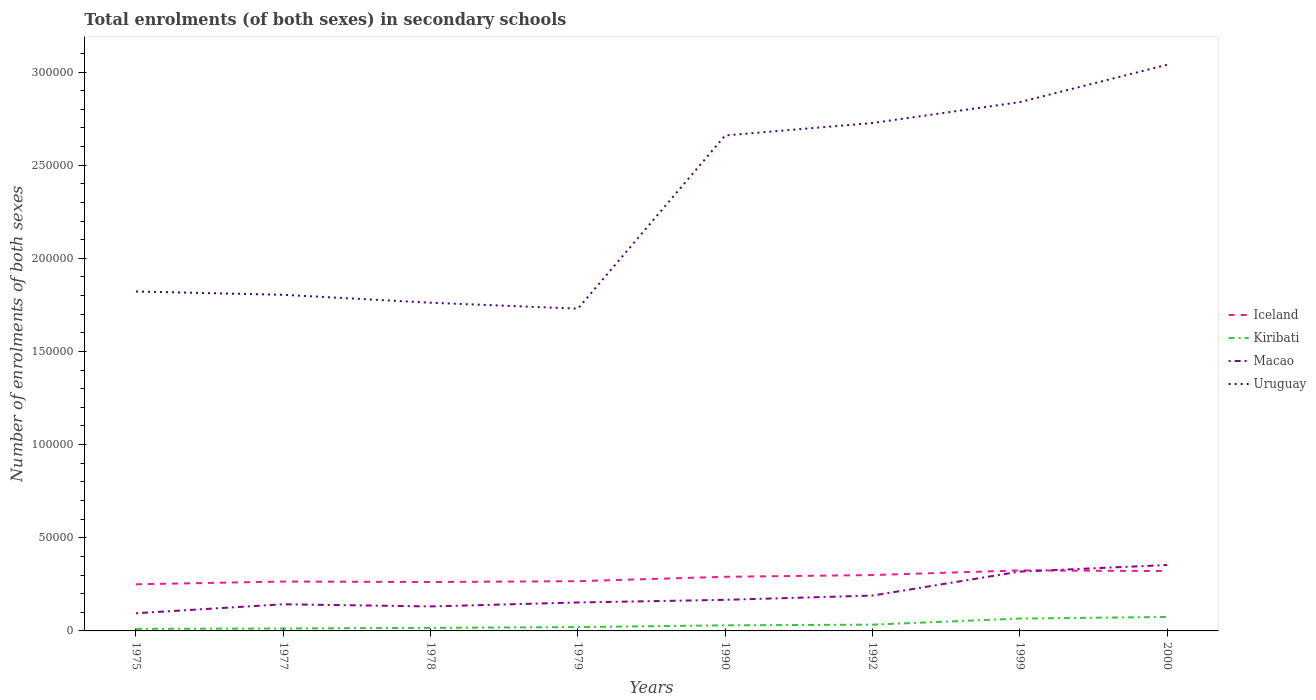Across all years, what is the maximum number of enrolments in secondary schools in Macao?
Give a very brief answer. 9498. In which year was the number of enrolments in secondary schools in Macao maximum?
Ensure brevity in your answer.  1975. What is the total number of enrolments in secondary schools in Macao in the graph?
Your response must be concise. -3508. What is the difference between the highest and the second highest number of enrolments in secondary schools in Iceland?
Ensure brevity in your answer.  7452. What is the difference between the highest and the lowest number of enrolments in secondary schools in Kiribati?
Your response must be concise. 3. Is the number of enrolments in secondary schools in Uruguay strictly greater than the number of enrolments in secondary schools in Iceland over the years?
Provide a short and direct response. No. How many lines are there?
Offer a terse response. 4. How many years are there in the graph?
Offer a terse response. 8. Where does the legend appear in the graph?
Offer a very short reply. Center right. How many legend labels are there?
Make the answer very short. 4. How are the legend labels stacked?
Make the answer very short. Vertical. What is the title of the graph?
Make the answer very short. Total enrolments (of both sexes) in secondary schools. Does "Suriname" appear as one of the legend labels in the graph?
Your response must be concise. No. What is the label or title of the Y-axis?
Your answer should be compact. Number of enrolments of both sexes. What is the Number of enrolments of both sexes of Iceland in 1975?
Keep it short and to the point. 2.50e+04. What is the Number of enrolments of both sexes in Kiribati in 1975?
Give a very brief answer. 1100. What is the Number of enrolments of both sexes in Macao in 1975?
Offer a terse response. 9498. What is the Number of enrolments of both sexes of Uruguay in 1975?
Give a very brief answer. 1.82e+05. What is the Number of enrolments of both sexes of Iceland in 1977?
Give a very brief answer. 2.65e+04. What is the Number of enrolments of both sexes in Kiribati in 1977?
Offer a terse response. 1300. What is the Number of enrolments of both sexes of Macao in 1977?
Your answer should be very brief. 1.43e+04. What is the Number of enrolments of both sexes in Uruguay in 1977?
Offer a very short reply. 1.80e+05. What is the Number of enrolments of both sexes of Iceland in 1978?
Offer a terse response. 2.63e+04. What is the Number of enrolments of both sexes of Kiribati in 1978?
Offer a very short reply. 1646. What is the Number of enrolments of both sexes in Macao in 1978?
Offer a terse response. 1.32e+04. What is the Number of enrolments of both sexes of Uruguay in 1978?
Provide a short and direct response. 1.76e+05. What is the Number of enrolments of both sexes in Iceland in 1979?
Give a very brief answer. 2.67e+04. What is the Number of enrolments of both sexes of Kiribati in 1979?
Give a very brief answer. 2062. What is the Number of enrolments of both sexes of Macao in 1979?
Provide a succinct answer. 1.53e+04. What is the Number of enrolments of both sexes of Uruguay in 1979?
Provide a short and direct response. 1.73e+05. What is the Number of enrolments of both sexes in Iceland in 1990?
Your answer should be very brief. 2.91e+04. What is the Number of enrolments of both sexes of Kiribati in 1990?
Keep it short and to the point. 3003. What is the Number of enrolments of both sexes of Macao in 1990?
Your answer should be compact. 1.67e+04. What is the Number of enrolments of both sexes of Uruguay in 1990?
Provide a succinct answer. 2.66e+05. What is the Number of enrolments of both sexes of Iceland in 1992?
Your answer should be compact. 3.00e+04. What is the Number of enrolments of both sexes of Kiribati in 1992?
Provide a short and direct response. 3357. What is the Number of enrolments of both sexes of Macao in 1992?
Your answer should be compact. 1.90e+04. What is the Number of enrolments of both sexes in Uruguay in 1992?
Make the answer very short. 2.73e+05. What is the Number of enrolments of both sexes in Iceland in 1999?
Offer a very short reply. 3.25e+04. What is the Number of enrolments of both sexes in Kiribati in 1999?
Offer a terse response. 6647. What is the Number of enrolments of both sexes of Macao in 1999?
Keep it short and to the point. 3.19e+04. What is the Number of enrolments of both sexes in Uruguay in 1999?
Your response must be concise. 2.84e+05. What is the Number of enrolments of both sexes of Iceland in 2000?
Ensure brevity in your answer.  3.21e+04. What is the Number of enrolments of both sexes in Kiribati in 2000?
Give a very brief answer. 7486. What is the Number of enrolments of both sexes in Macao in 2000?
Offer a very short reply. 3.54e+04. What is the Number of enrolments of both sexes of Uruguay in 2000?
Make the answer very short. 3.04e+05. Across all years, what is the maximum Number of enrolments of both sexes in Iceland?
Provide a succinct answer. 3.25e+04. Across all years, what is the maximum Number of enrolments of both sexes of Kiribati?
Your answer should be very brief. 7486. Across all years, what is the maximum Number of enrolments of both sexes in Macao?
Offer a very short reply. 3.54e+04. Across all years, what is the maximum Number of enrolments of both sexes of Uruguay?
Offer a terse response. 3.04e+05. Across all years, what is the minimum Number of enrolments of both sexes of Iceland?
Keep it short and to the point. 2.50e+04. Across all years, what is the minimum Number of enrolments of both sexes in Kiribati?
Offer a very short reply. 1100. Across all years, what is the minimum Number of enrolments of both sexes in Macao?
Your response must be concise. 9498. Across all years, what is the minimum Number of enrolments of both sexes of Uruguay?
Keep it short and to the point. 1.73e+05. What is the total Number of enrolments of both sexes of Iceland in the graph?
Offer a very short reply. 2.28e+05. What is the total Number of enrolments of both sexes of Kiribati in the graph?
Provide a short and direct response. 2.66e+04. What is the total Number of enrolments of both sexes in Macao in the graph?
Keep it short and to the point. 1.55e+05. What is the total Number of enrolments of both sexes in Uruguay in the graph?
Make the answer very short. 1.84e+06. What is the difference between the Number of enrolments of both sexes in Iceland in 1975 and that in 1977?
Keep it short and to the point. -1478. What is the difference between the Number of enrolments of both sexes of Kiribati in 1975 and that in 1977?
Make the answer very short. -200. What is the difference between the Number of enrolments of both sexes in Macao in 1975 and that in 1977?
Make the answer very short. -4807. What is the difference between the Number of enrolments of both sexes of Uruguay in 1975 and that in 1977?
Ensure brevity in your answer.  1777. What is the difference between the Number of enrolments of both sexes in Iceland in 1975 and that in 1978?
Give a very brief answer. -1223. What is the difference between the Number of enrolments of both sexes in Kiribati in 1975 and that in 1978?
Offer a very short reply. -546. What is the difference between the Number of enrolments of both sexes of Macao in 1975 and that in 1978?
Provide a short and direct response. -3652. What is the difference between the Number of enrolments of both sexes in Uruguay in 1975 and that in 1978?
Your answer should be compact. 6028. What is the difference between the Number of enrolments of both sexes of Iceland in 1975 and that in 1979?
Your answer should be very brief. -1671. What is the difference between the Number of enrolments of both sexes of Kiribati in 1975 and that in 1979?
Provide a succinct answer. -962. What is the difference between the Number of enrolments of both sexes in Macao in 1975 and that in 1979?
Give a very brief answer. -5770. What is the difference between the Number of enrolments of both sexes of Uruguay in 1975 and that in 1979?
Offer a very short reply. 9226. What is the difference between the Number of enrolments of both sexes in Iceland in 1975 and that in 1990?
Keep it short and to the point. -4031. What is the difference between the Number of enrolments of both sexes of Kiribati in 1975 and that in 1990?
Your answer should be very brief. -1903. What is the difference between the Number of enrolments of both sexes in Macao in 1975 and that in 1990?
Your answer should be compact. -7189. What is the difference between the Number of enrolments of both sexes in Uruguay in 1975 and that in 1990?
Offer a terse response. -8.38e+04. What is the difference between the Number of enrolments of both sexes in Iceland in 1975 and that in 1992?
Your answer should be very brief. -4957. What is the difference between the Number of enrolments of both sexes in Kiribati in 1975 and that in 1992?
Offer a terse response. -2257. What is the difference between the Number of enrolments of both sexes of Macao in 1975 and that in 1992?
Offer a very short reply. -9480. What is the difference between the Number of enrolments of both sexes of Uruguay in 1975 and that in 1992?
Offer a terse response. -9.04e+04. What is the difference between the Number of enrolments of both sexes of Iceland in 1975 and that in 1999?
Ensure brevity in your answer.  -7452. What is the difference between the Number of enrolments of both sexes in Kiribati in 1975 and that in 1999?
Ensure brevity in your answer.  -5547. What is the difference between the Number of enrolments of both sexes of Macao in 1975 and that in 1999?
Your response must be concise. -2.24e+04. What is the difference between the Number of enrolments of both sexes of Uruguay in 1975 and that in 1999?
Offer a very short reply. -1.02e+05. What is the difference between the Number of enrolments of both sexes in Iceland in 1975 and that in 2000?
Give a very brief answer. -7105. What is the difference between the Number of enrolments of both sexes of Kiribati in 1975 and that in 2000?
Make the answer very short. -6386. What is the difference between the Number of enrolments of both sexes in Macao in 1975 and that in 2000?
Provide a short and direct response. -2.59e+04. What is the difference between the Number of enrolments of both sexes of Uruguay in 1975 and that in 2000?
Keep it short and to the point. -1.22e+05. What is the difference between the Number of enrolments of both sexes of Iceland in 1977 and that in 1978?
Ensure brevity in your answer.  255. What is the difference between the Number of enrolments of both sexes in Kiribati in 1977 and that in 1978?
Your answer should be very brief. -346. What is the difference between the Number of enrolments of both sexes of Macao in 1977 and that in 1978?
Your response must be concise. 1155. What is the difference between the Number of enrolments of both sexes in Uruguay in 1977 and that in 1978?
Provide a succinct answer. 4251. What is the difference between the Number of enrolments of both sexes in Iceland in 1977 and that in 1979?
Keep it short and to the point. -193. What is the difference between the Number of enrolments of both sexes of Kiribati in 1977 and that in 1979?
Provide a short and direct response. -762. What is the difference between the Number of enrolments of both sexes in Macao in 1977 and that in 1979?
Your response must be concise. -963. What is the difference between the Number of enrolments of both sexes of Uruguay in 1977 and that in 1979?
Make the answer very short. 7449. What is the difference between the Number of enrolments of both sexes in Iceland in 1977 and that in 1990?
Your response must be concise. -2553. What is the difference between the Number of enrolments of both sexes in Kiribati in 1977 and that in 1990?
Provide a short and direct response. -1703. What is the difference between the Number of enrolments of both sexes in Macao in 1977 and that in 1990?
Your answer should be very brief. -2382. What is the difference between the Number of enrolments of both sexes in Uruguay in 1977 and that in 1990?
Offer a very short reply. -8.55e+04. What is the difference between the Number of enrolments of both sexes in Iceland in 1977 and that in 1992?
Offer a very short reply. -3479. What is the difference between the Number of enrolments of both sexes in Kiribati in 1977 and that in 1992?
Provide a succinct answer. -2057. What is the difference between the Number of enrolments of both sexes in Macao in 1977 and that in 1992?
Ensure brevity in your answer.  -4673. What is the difference between the Number of enrolments of both sexes of Uruguay in 1977 and that in 1992?
Offer a terse response. -9.22e+04. What is the difference between the Number of enrolments of both sexes in Iceland in 1977 and that in 1999?
Keep it short and to the point. -5974. What is the difference between the Number of enrolments of both sexes of Kiribati in 1977 and that in 1999?
Your answer should be very brief. -5347. What is the difference between the Number of enrolments of both sexes in Macao in 1977 and that in 1999?
Provide a short and direct response. -1.76e+04. What is the difference between the Number of enrolments of both sexes in Uruguay in 1977 and that in 1999?
Offer a very short reply. -1.03e+05. What is the difference between the Number of enrolments of both sexes in Iceland in 1977 and that in 2000?
Make the answer very short. -5627. What is the difference between the Number of enrolments of both sexes in Kiribati in 1977 and that in 2000?
Provide a succinct answer. -6186. What is the difference between the Number of enrolments of both sexes in Macao in 1977 and that in 2000?
Offer a very short reply. -2.11e+04. What is the difference between the Number of enrolments of both sexes in Uruguay in 1977 and that in 2000?
Provide a succinct answer. -1.23e+05. What is the difference between the Number of enrolments of both sexes in Iceland in 1978 and that in 1979?
Give a very brief answer. -448. What is the difference between the Number of enrolments of both sexes in Kiribati in 1978 and that in 1979?
Your answer should be very brief. -416. What is the difference between the Number of enrolments of both sexes in Macao in 1978 and that in 1979?
Make the answer very short. -2118. What is the difference between the Number of enrolments of both sexes in Uruguay in 1978 and that in 1979?
Make the answer very short. 3198. What is the difference between the Number of enrolments of both sexes in Iceland in 1978 and that in 1990?
Keep it short and to the point. -2808. What is the difference between the Number of enrolments of both sexes in Kiribati in 1978 and that in 1990?
Give a very brief answer. -1357. What is the difference between the Number of enrolments of both sexes in Macao in 1978 and that in 1990?
Provide a succinct answer. -3537. What is the difference between the Number of enrolments of both sexes in Uruguay in 1978 and that in 1990?
Provide a succinct answer. -8.98e+04. What is the difference between the Number of enrolments of both sexes in Iceland in 1978 and that in 1992?
Provide a succinct answer. -3734. What is the difference between the Number of enrolments of both sexes in Kiribati in 1978 and that in 1992?
Your answer should be compact. -1711. What is the difference between the Number of enrolments of both sexes in Macao in 1978 and that in 1992?
Offer a very short reply. -5828. What is the difference between the Number of enrolments of both sexes in Uruguay in 1978 and that in 1992?
Provide a short and direct response. -9.65e+04. What is the difference between the Number of enrolments of both sexes in Iceland in 1978 and that in 1999?
Offer a very short reply. -6229. What is the difference between the Number of enrolments of both sexes in Kiribati in 1978 and that in 1999?
Offer a very short reply. -5001. What is the difference between the Number of enrolments of both sexes of Macao in 1978 and that in 1999?
Your answer should be compact. -1.87e+04. What is the difference between the Number of enrolments of both sexes in Uruguay in 1978 and that in 1999?
Your answer should be compact. -1.08e+05. What is the difference between the Number of enrolments of both sexes of Iceland in 1978 and that in 2000?
Give a very brief answer. -5882. What is the difference between the Number of enrolments of both sexes of Kiribati in 1978 and that in 2000?
Provide a short and direct response. -5840. What is the difference between the Number of enrolments of both sexes of Macao in 1978 and that in 2000?
Your answer should be compact. -2.22e+04. What is the difference between the Number of enrolments of both sexes of Uruguay in 1978 and that in 2000?
Provide a succinct answer. -1.28e+05. What is the difference between the Number of enrolments of both sexes in Iceland in 1979 and that in 1990?
Provide a short and direct response. -2360. What is the difference between the Number of enrolments of both sexes in Kiribati in 1979 and that in 1990?
Ensure brevity in your answer.  -941. What is the difference between the Number of enrolments of both sexes in Macao in 1979 and that in 1990?
Ensure brevity in your answer.  -1419. What is the difference between the Number of enrolments of both sexes in Uruguay in 1979 and that in 1990?
Provide a succinct answer. -9.30e+04. What is the difference between the Number of enrolments of both sexes in Iceland in 1979 and that in 1992?
Offer a very short reply. -3286. What is the difference between the Number of enrolments of both sexes in Kiribati in 1979 and that in 1992?
Provide a short and direct response. -1295. What is the difference between the Number of enrolments of both sexes of Macao in 1979 and that in 1992?
Offer a very short reply. -3710. What is the difference between the Number of enrolments of both sexes of Uruguay in 1979 and that in 1992?
Make the answer very short. -9.97e+04. What is the difference between the Number of enrolments of both sexes in Iceland in 1979 and that in 1999?
Your answer should be compact. -5781. What is the difference between the Number of enrolments of both sexes of Kiribati in 1979 and that in 1999?
Provide a short and direct response. -4585. What is the difference between the Number of enrolments of both sexes in Macao in 1979 and that in 1999?
Keep it short and to the point. -1.66e+04. What is the difference between the Number of enrolments of both sexes in Uruguay in 1979 and that in 1999?
Provide a short and direct response. -1.11e+05. What is the difference between the Number of enrolments of both sexes in Iceland in 1979 and that in 2000?
Give a very brief answer. -5434. What is the difference between the Number of enrolments of both sexes in Kiribati in 1979 and that in 2000?
Ensure brevity in your answer.  -5424. What is the difference between the Number of enrolments of both sexes in Macao in 1979 and that in 2000?
Your response must be concise. -2.01e+04. What is the difference between the Number of enrolments of both sexes in Uruguay in 1979 and that in 2000?
Your response must be concise. -1.31e+05. What is the difference between the Number of enrolments of both sexes of Iceland in 1990 and that in 1992?
Ensure brevity in your answer.  -926. What is the difference between the Number of enrolments of both sexes in Kiribati in 1990 and that in 1992?
Make the answer very short. -354. What is the difference between the Number of enrolments of both sexes of Macao in 1990 and that in 1992?
Offer a terse response. -2291. What is the difference between the Number of enrolments of both sexes in Uruguay in 1990 and that in 1992?
Your answer should be very brief. -6675. What is the difference between the Number of enrolments of both sexes in Iceland in 1990 and that in 1999?
Keep it short and to the point. -3421. What is the difference between the Number of enrolments of both sexes of Kiribati in 1990 and that in 1999?
Make the answer very short. -3644. What is the difference between the Number of enrolments of both sexes in Macao in 1990 and that in 1999?
Offer a terse response. -1.52e+04. What is the difference between the Number of enrolments of both sexes of Uruguay in 1990 and that in 1999?
Offer a terse response. -1.79e+04. What is the difference between the Number of enrolments of both sexes in Iceland in 1990 and that in 2000?
Your answer should be very brief. -3074. What is the difference between the Number of enrolments of both sexes of Kiribati in 1990 and that in 2000?
Your response must be concise. -4483. What is the difference between the Number of enrolments of both sexes in Macao in 1990 and that in 2000?
Provide a succinct answer. -1.87e+04. What is the difference between the Number of enrolments of both sexes in Uruguay in 1990 and that in 2000?
Your response must be concise. -3.79e+04. What is the difference between the Number of enrolments of both sexes of Iceland in 1992 and that in 1999?
Make the answer very short. -2495. What is the difference between the Number of enrolments of both sexes of Kiribati in 1992 and that in 1999?
Offer a terse response. -3290. What is the difference between the Number of enrolments of both sexes in Macao in 1992 and that in 1999?
Provide a succinct answer. -1.29e+04. What is the difference between the Number of enrolments of both sexes in Uruguay in 1992 and that in 1999?
Provide a short and direct response. -1.12e+04. What is the difference between the Number of enrolments of both sexes of Iceland in 1992 and that in 2000?
Give a very brief answer. -2148. What is the difference between the Number of enrolments of both sexes in Kiribati in 1992 and that in 2000?
Make the answer very short. -4129. What is the difference between the Number of enrolments of both sexes in Macao in 1992 and that in 2000?
Provide a short and direct response. -1.64e+04. What is the difference between the Number of enrolments of both sexes in Uruguay in 1992 and that in 2000?
Ensure brevity in your answer.  -3.13e+04. What is the difference between the Number of enrolments of both sexes of Iceland in 1999 and that in 2000?
Your answer should be very brief. 347. What is the difference between the Number of enrolments of both sexes of Kiribati in 1999 and that in 2000?
Keep it short and to the point. -839. What is the difference between the Number of enrolments of both sexes of Macao in 1999 and that in 2000?
Provide a short and direct response. -3508. What is the difference between the Number of enrolments of both sexes of Uruguay in 1999 and that in 2000?
Give a very brief answer. -2.00e+04. What is the difference between the Number of enrolments of both sexes in Iceland in 1975 and the Number of enrolments of both sexes in Kiribati in 1977?
Your response must be concise. 2.37e+04. What is the difference between the Number of enrolments of both sexes of Iceland in 1975 and the Number of enrolments of both sexes of Macao in 1977?
Keep it short and to the point. 1.07e+04. What is the difference between the Number of enrolments of both sexes in Iceland in 1975 and the Number of enrolments of both sexes in Uruguay in 1977?
Make the answer very short. -1.55e+05. What is the difference between the Number of enrolments of both sexes of Kiribati in 1975 and the Number of enrolments of both sexes of Macao in 1977?
Your answer should be very brief. -1.32e+04. What is the difference between the Number of enrolments of both sexes of Kiribati in 1975 and the Number of enrolments of both sexes of Uruguay in 1977?
Offer a terse response. -1.79e+05. What is the difference between the Number of enrolments of both sexes of Macao in 1975 and the Number of enrolments of both sexes of Uruguay in 1977?
Ensure brevity in your answer.  -1.71e+05. What is the difference between the Number of enrolments of both sexes of Iceland in 1975 and the Number of enrolments of both sexes of Kiribati in 1978?
Provide a short and direct response. 2.34e+04. What is the difference between the Number of enrolments of both sexes of Iceland in 1975 and the Number of enrolments of both sexes of Macao in 1978?
Provide a short and direct response. 1.19e+04. What is the difference between the Number of enrolments of both sexes in Iceland in 1975 and the Number of enrolments of both sexes in Uruguay in 1978?
Your answer should be very brief. -1.51e+05. What is the difference between the Number of enrolments of both sexes of Kiribati in 1975 and the Number of enrolments of both sexes of Macao in 1978?
Your response must be concise. -1.20e+04. What is the difference between the Number of enrolments of both sexes of Kiribati in 1975 and the Number of enrolments of both sexes of Uruguay in 1978?
Provide a short and direct response. -1.75e+05. What is the difference between the Number of enrolments of both sexes of Macao in 1975 and the Number of enrolments of both sexes of Uruguay in 1978?
Provide a succinct answer. -1.67e+05. What is the difference between the Number of enrolments of both sexes in Iceland in 1975 and the Number of enrolments of both sexes in Kiribati in 1979?
Give a very brief answer. 2.30e+04. What is the difference between the Number of enrolments of both sexes of Iceland in 1975 and the Number of enrolments of both sexes of Macao in 1979?
Provide a succinct answer. 9760. What is the difference between the Number of enrolments of both sexes in Iceland in 1975 and the Number of enrolments of both sexes in Uruguay in 1979?
Your answer should be very brief. -1.48e+05. What is the difference between the Number of enrolments of both sexes of Kiribati in 1975 and the Number of enrolments of both sexes of Macao in 1979?
Offer a terse response. -1.42e+04. What is the difference between the Number of enrolments of both sexes in Kiribati in 1975 and the Number of enrolments of both sexes in Uruguay in 1979?
Offer a terse response. -1.72e+05. What is the difference between the Number of enrolments of both sexes in Macao in 1975 and the Number of enrolments of both sexes in Uruguay in 1979?
Give a very brief answer. -1.63e+05. What is the difference between the Number of enrolments of both sexes of Iceland in 1975 and the Number of enrolments of both sexes of Kiribati in 1990?
Ensure brevity in your answer.  2.20e+04. What is the difference between the Number of enrolments of both sexes in Iceland in 1975 and the Number of enrolments of both sexes in Macao in 1990?
Your answer should be very brief. 8341. What is the difference between the Number of enrolments of both sexes of Iceland in 1975 and the Number of enrolments of both sexes of Uruguay in 1990?
Your answer should be very brief. -2.41e+05. What is the difference between the Number of enrolments of both sexes in Kiribati in 1975 and the Number of enrolments of both sexes in Macao in 1990?
Provide a short and direct response. -1.56e+04. What is the difference between the Number of enrolments of both sexes of Kiribati in 1975 and the Number of enrolments of both sexes of Uruguay in 1990?
Your answer should be compact. -2.65e+05. What is the difference between the Number of enrolments of both sexes of Macao in 1975 and the Number of enrolments of both sexes of Uruguay in 1990?
Give a very brief answer. -2.56e+05. What is the difference between the Number of enrolments of both sexes of Iceland in 1975 and the Number of enrolments of both sexes of Kiribati in 1992?
Make the answer very short. 2.17e+04. What is the difference between the Number of enrolments of both sexes in Iceland in 1975 and the Number of enrolments of both sexes in Macao in 1992?
Provide a short and direct response. 6050. What is the difference between the Number of enrolments of both sexes in Iceland in 1975 and the Number of enrolments of both sexes in Uruguay in 1992?
Ensure brevity in your answer.  -2.48e+05. What is the difference between the Number of enrolments of both sexes of Kiribati in 1975 and the Number of enrolments of both sexes of Macao in 1992?
Provide a succinct answer. -1.79e+04. What is the difference between the Number of enrolments of both sexes in Kiribati in 1975 and the Number of enrolments of both sexes in Uruguay in 1992?
Make the answer very short. -2.72e+05. What is the difference between the Number of enrolments of both sexes of Macao in 1975 and the Number of enrolments of both sexes of Uruguay in 1992?
Your answer should be compact. -2.63e+05. What is the difference between the Number of enrolments of both sexes of Iceland in 1975 and the Number of enrolments of both sexes of Kiribati in 1999?
Provide a succinct answer. 1.84e+04. What is the difference between the Number of enrolments of both sexes of Iceland in 1975 and the Number of enrolments of both sexes of Macao in 1999?
Your response must be concise. -6831. What is the difference between the Number of enrolments of both sexes of Iceland in 1975 and the Number of enrolments of both sexes of Uruguay in 1999?
Keep it short and to the point. -2.59e+05. What is the difference between the Number of enrolments of both sexes of Kiribati in 1975 and the Number of enrolments of both sexes of Macao in 1999?
Ensure brevity in your answer.  -3.08e+04. What is the difference between the Number of enrolments of both sexes in Kiribati in 1975 and the Number of enrolments of both sexes in Uruguay in 1999?
Offer a very short reply. -2.83e+05. What is the difference between the Number of enrolments of both sexes of Macao in 1975 and the Number of enrolments of both sexes of Uruguay in 1999?
Offer a terse response. -2.74e+05. What is the difference between the Number of enrolments of both sexes of Iceland in 1975 and the Number of enrolments of both sexes of Kiribati in 2000?
Provide a succinct answer. 1.75e+04. What is the difference between the Number of enrolments of both sexes of Iceland in 1975 and the Number of enrolments of both sexes of Macao in 2000?
Your answer should be compact. -1.03e+04. What is the difference between the Number of enrolments of both sexes of Iceland in 1975 and the Number of enrolments of both sexes of Uruguay in 2000?
Your answer should be very brief. -2.79e+05. What is the difference between the Number of enrolments of both sexes of Kiribati in 1975 and the Number of enrolments of both sexes of Macao in 2000?
Keep it short and to the point. -3.43e+04. What is the difference between the Number of enrolments of both sexes in Kiribati in 1975 and the Number of enrolments of both sexes in Uruguay in 2000?
Your response must be concise. -3.03e+05. What is the difference between the Number of enrolments of both sexes in Macao in 1975 and the Number of enrolments of both sexes in Uruguay in 2000?
Your answer should be compact. -2.94e+05. What is the difference between the Number of enrolments of both sexes of Iceland in 1977 and the Number of enrolments of both sexes of Kiribati in 1978?
Offer a very short reply. 2.49e+04. What is the difference between the Number of enrolments of both sexes of Iceland in 1977 and the Number of enrolments of both sexes of Macao in 1978?
Your answer should be very brief. 1.34e+04. What is the difference between the Number of enrolments of both sexes in Iceland in 1977 and the Number of enrolments of both sexes in Uruguay in 1978?
Provide a short and direct response. -1.50e+05. What is the difference between the Number of enrolments of both sexes in Kiribati in 1977 and the Number of enrolments of both sexes in Macao in 1978?
Your answer should be very brief. -1.18e+04. What is the difference between the Number of enrolments of both sexes of Kiribati in 1977 and the Number of enrolments of both sexes of Uruguay in 1978?
Give a very brief answer. -1.75e+05. What is the difference between the Number of enrolments of both sexes in Macao in 1977 and the Number of enrolments of both sexes in Uruguay in 1978?
Your answer should be very brief. -1.62e+05. What is the difference between the Number of enrolments of both sexes of Iceland in 1977 and the Number of enrolments of both sexes of Kiribati in 1979?
Offer a terse response. 2.44e+04. What is the difference between the Number of enrolments of both sexes of Iceland in 1977 and the Number of enrolments of both sexes of Macao in 1979?
Offer a terse response. 1.12e+04. What is the difference between the Number of enrolments of both sexes in Iceland in 1977 and the Number of enrolments of both sexes in Uruguay in 1979?
Ensure brevity in your answer.  -1.46e+05. What is the difference between the Number of enrolments of both sexes in Kiribati in 1977 and the Number of enrolments of both sexes in Macao in 1979?
Keep it short and to the point. -1.40e+04. What is the difference between the Number of enrolments of both sexes in Kiribati in 1977 and the Number of enrolments of both sexes in Uruguay in 1979?
Keep it short and to the point. -1.72e+05. What is the difference between the Number of enrolments of both sexes of Macao in 1977 and the Number of enrolments of both sexes of Uruguay in 1979?
Ensure brevity in your answer.  -1.59e+05. What is the difference between the Number of enrolments of both sexes of Iceland in 1977 and the Number of enrolments of both sexes of Kiribati in 1990?
Provide a succinct answer. 2.35e+04. What is the difference between the Number of enrolments of both sexes in Iceland in 1977 and the Number of enrolments of both sexes in Macao in 1990?
Ensure brevity in your answer.  9819. What is the difference between the Number of enrolments of both sexes of Iceland in 1977 and the Number of enrolments of both sexes of Uruguay in 1990?
Offer a terse response. -2.39e+05. What is the difference between the Number of enrolments of both sexes of Kiribati in 1977 and the Number of enrolments of both sexes of Macao in 1990?
Make the answer very short. -1.54e+04. What is the difference between the Number of enrolments of both sexes in Kiribati in 1977 and the Number of enrolments of both sexes in Uruguay in 1990?
Your answer should be compact. -2.65e+05. What is the difference between the Number of enrolments of both sexes of Macao in 1977 and the Number of enrolments of both sexes of Uruguay in 1990?
Offer a very short reply. -2.52e+05. What is the difference between the Number of enrolments of both sexes of Iceland in 1977 and the Number of enrolments of both sexes of Kiribati in 1992?
Provide a succinct answer. 2.31e+04. What is the difference between the Number of enrolments of both sexes in Iceland in 1977 and the Number of enrolments of both sexes in Macao in 1992?
Your response must be concise. 7528. What is the difference between the Number of enrolments of both sexes of Iceland in 1977 and the Number of enrolments of both sexes of Uruguay in 1992?
Provide a succinct answer. -2.46e+05. What is the difference between the Number of enrolments of both sexes of Kiribati in 1977 and the Number of enrolments of both sexes of Macao in 1992?
Your answer should be very brief. -1.77e+04. What is the difference between the Number of enrolments of both sexes in Kiribati in 1977 and the Number of enrolments of both sexes in Uruguay in 1992?
Offer a very short reply. -2.71e+05. What is the difference between the Number of enrolments of both sexes in Macao in 1977 and the Number of enrolments of both sexes in Uruguay in 1992?
Give a very brief answer. -2.58e+05. What is the difference between the Number of enrolments of both sexes in Iceland in 1977 and the Number of enrolments of both sexes in Kiribati in 1999?
Provide a short and direct response. 1.99e+04. What is the difference between the Number of enrolments of both sexes in Iceland in 1977 and the Number of enrolments of both sexes in Macao in 1999?
Provide a succinct answer. -5353. What is the difference between the Number of enrolments of both sexes of Iceland in 1977 and the Number of enrolments of both sexes of Uruguay in 1999?
Offer a very short reply. -2.57e+05. What is the difference between the Number of enrolments of both sexes of Kiribati in 1977 and the Number of enrolments of both sexes of Macao in 1999?
Ensure brevity in your answer.  -3.06e+04. What is the difference between the Number of enrolments of both sexes in Kiribati in 1977 and the Number of enrolments of both sexes in Uruguay in 1999?
Offer a terse response. -2.83e+05. What is the difference between the Number of enrolments of both sexes in Macao in 1977 and the Number of enrolments of both sexes in Uruguay in 1999?
Make the answer very short. -2.70e+05. What is the difference between the Number of enrolments of both sexes of Iceland in 1977 and the Number of enrolments of both sexes of Kiribati in 2000?
Offer a terse response. 1.90e+04. What is the difference between the Number of enrolments of both sexes in Iceland in 1977 and the Number of enrolments of both sexes in Macao in 2000?
Your answer should be compact. -8861. What is the difference between the Number of enrolments of both sexes of Iceland in 1977 and the Number of enrolments of both sexes of Uruguay in 2000?
Make the answer very short. -2.77e+05. What is the difference between the Number of enrolments of both sexes of Kiribati in 1977 and the Number of enrolments of both sexes of Macao in 2000?
Your answer should be compact. -3.41e+04. What is the difference between the Number of enrolments of both sexes of Kiribati in 1977 and the Number of enrolments of both sexes of Uruguay in 2000?
Your answer should be very brief. -3.03e+05. What is the difference between the Number of enrolments of both sexes in Macao in 1977 and the Number of enrolments of both sexes in Uruguay in 2000?
Offer a very short reply. -2.90e+05. What is the difference between the Number of enrolments of both sexes of Iceland in 1978 and the Number of enrolments of both sexes of Kiribati in 1979?
Offer a very short reply. 2.42e+04. What is the difference between the Number of enrolments of both sexes in Iceland in 1978 and the Number of enrolments of both sexes in Macao in 1979?
Your answer should be compact. 1.10e+04. What is the difference between the Number of enrolments of both sexes of Iceland in 1978 and the Number of enrolments of both sexes of Uruguay in 1979?
Your answer should be very brief. -1.47e+05. What is the difference between the Number of enrolments of both sexes in Kiribati in 1978 and the Number of enrolments of both sexes in Macao in 1979?
Offer a terse response. -1.36e+04. What is the difference between the Number of enrolments of both sexes in Kiribati in 1978 and the Number of enrolments of both sexes in Uruguay in 1979?
Ensure brevity in your answer.  -1.71e+05. What is the difference between the Number of enrolments of both sexes of Macao in 1978 and the Number of enrolments of both sexes of Uruguay in 1979?
Your response must be concise. -1.60e+05. What is the difference between the Number of enrolments of both sexes of Iceland in 1978 and the Number of enrolments of both sexes of Kiribati in 1990?
Your answer should be compact. 2.32e+04. What is the difference between the Number of enrolments of both sexes in Iceland in 1978 and the Number of enrolments of both sexes in Macao in 1990?
Provide a succinct answer. 9564. What is the difference between the Number of enrolments of both sexes of Iceland in 1978 and the Number of enrolments of both sexes of Uruguay in 1990?
Your response must be concise. -2.40e+05. What is the difference between the Number of enrolments of both sexes in Kiribati in 1978 and the Number of enrolments of both sexes in Macao in 1990?
Provide a short and direct response. -1.50e+04. What is the difference between the Number of enrolments of both sexes of Kiribati in 1978 and the Number of enrolments of both sexes of Uruguay in 1990?
Offer a terse response. -2.64e+05. What is the difference between the Number of enrolments of both sexes of Macao in 1978 and the Number of enrolments of both sexes of Uruguay in 1990?
Offer a very short reply. -2.53e+05. What is the difference between the Number of enrolments of both sexes in Iceland in 1978 and the Number of enrolments of both sexes in Kiribati in 1992?
Keep it short and to the point. 2.29e+04. What is the difference between the Number of enrolments of both sexes in Iceland in 1978 and the Number of enrolments of both sexes in Macao in 1992?
Give a very brief answer. 7273. What is the difference between the Number of enrolments of both sexes in Iceland in 1978 and the Number of enrolments of both sexes in Uruguay in 1992?
Your answer should be very brief. -2.46e+05. What is the difference between the Number of enrolments of both sexes in Kiribati in 1978 and the Number of enrolments of both sexes in Macao in 1992?
Make the answer very short. -1.73e+04. What is the difference between the Number of enrolments of both sexes in Kiribati in 1978 and the Number of enrolments of both sexes in Uruguay in 1992?
Offer a terse response. -2.71e+05. What is the difference between the Number of enrolments of both sexes of Macao in 1978 and the Number of enrolments of both sexes of Uruguay in 1992?
Make the answer very short. -2.59e+05. What is the difference between the Number of enrolments of both sexes in Iceland in 1978 and the Number of enrolments of both sexes in Kiribati in 1999?
Make the answer very short. 1.96e+04. What is the difference between the Number of enrolments of both sexes of Iceland in 1978 and the Number of enrolments of both sexes of Macao in 1999?
Ensure brevity in your answer.  -5608. What is the difference between the Number of enrolments of both sexes in Iceland in 1978 and the Number of enrolments of both sexes in Uruguay in 1999?
Provide a short and direct response. -2.58e+05. What is the difference between the Number of enrolments of both sexes in Kiribati in 1978 and the Number of enrolments of both sexes in Macao in 1999?
Provide a short and direct response. -3.02e+04. What is the difference between the Number of enrolments of both sexes of Kiribati in 1978 and the Number of enrolments of both sexes of Uruguay in 1999?
Give a very brief answer. -2.82e+05. What is the difference between the Number of enrolments of both sexes of Macao in 1978 and the Number of enrolments of both sexes of Uruguay in 1999?
Provide a succinct answer. -2.71e+05. What is the difference between the Number of enrolments of both sexes of Iceland in 1978 and the Number of enrolments of both sexes of Kiribati in 2000?
Your answer should be very brief. 1.88e+04. What is the difference between the Number of enrolments of both sexes in Iceland in 1978 and the Number of enrolments of both sexes in Macao in 2000?
Offer a terse response. -9116. What is the difference between the Number of enrolments of both sexes of Iceland in 1978 and the Number of enrolments of both sexes of Uruguay in 2000?
Give a very brief answer. -2.78e+05. What is the difference between the Number of enrolments of both sexes of Kiribati in 1978 and the Number of enrolments of both sexes of Macao in 2000?
Offer a very short reply. -3.37e+04. What is the difference between the Number of enrolments of both sexes of Kiribati in 1978 and the Number of enrolments of both sexes of Uruguay in 2000?
Offer a terse response. -3.02e+05. What is the difference between the Number of enrolments of both sexes in Macao in 1978 and the Number of enrolments of both sexes in Uruguay in 2000?
Give a very brief answer. -2.91e+05. What is the difference between the Number of enrolments of both sexes of Iceland in 1979 and the Number of enrolments of both sexes of Kiribati in 1990?
Your answer should be compact. 2.37e+04. What is the difference between the Number of enrolments of both sexes in Iceland in 1979 and the Number of enrolments of both sexes in Macao in 1990?
Make the answer very short. 1.00e+04. What is the difference between the Number of enrolments of both sexes of Iceland in 1979 and the Number of enrolments of both sexes of Uruguay in 1990?
Give a very brief answer. -2.39e+05. What is the difference between the Number of enrolments of both sexes of Kiribati in 1979 and the Number of enrolments of both sexes of Macao in 1990?
Provide a succinct answer. -1.46e+04. What is the difference between the Number of enrolments of both sexes of Kiribati in 1979 and the Number of enrolments of both sexes of Uruguay in 1990?
Make the answer very short. -2.64e+05. What is the difference between the Number of enrolments of both sexes in Macao in 1979 and the Number of enrolments of both sexes in Uruguay in 1990?
Make the answer very short. -2.51e+05. What is the difference between the Number of enrolments of both sexes of Iceland in 1979 and the Number of enrolments of both sexes of Kiribati in 1992?
Provide a short and direct response. 2.33e+04. What is the difference between the Number of enrolments of both sexes of Iceland in 1979 and the Number of enrolments of both sexes of Macao in 1992?
Provide a succinct answer. 7721. What is the difference between the Number of enrolments of both sexes in Iceland in 1979 and the Number of enrolments of both sexes in Uruguay in 1992?
Make the answer very short. -2.46e+05. What is the difference between the Number of enrolments of both sexes of Kiribati in 1979 and the Number of enrolments of both sexes of Macao in 1992?
Give a very brief answer. -1.69e+04. What is the difference between the Number of enrolments of both sexes of Kiribati in 1979 and the Number of enrolments of both sexes of Uruguay in 1992?
Provide a short and direct response. -2.71e+05. What is the difference between the Number of enrolments of both sexes in Macao in 1979 and the Number of enrolments of both sexes in Uruguay in 1992?
Offer a terse response. -2.57e+05. What is the difference between the Number of enrolments of both sexes in Iceland in 1979 and the Number of enrolments of both sexes in Kiribati in 1999?
Offer a very short reply. 2.01e+04. What is the difference between the Number of enrolments of both sexes of Iceland in 1979 and the Number of enrolments of both sexes of Macao in 1999?
Provide a succinct answer. -5160. What is the difference between the Number of enrolments of both sexes of Iceland in 1979 and the Number of enrolments of both sexes of Uruguay in 1999?
Give a very brief answer. -2.57e+05. What is the difference between the Number of enrolments of both sexes in Kiribati in 1979 and the Number of enrolments of both sexes in Macao in 1999?
Ensure brevity in your answer.  -2.98e+04. What is the difference between the Number of enrolments of both sexes of Kiribati in 1979 and the Number of enrolments of both sexes of Uruguay in 1999?
Offer a very short reply. -2.82e+05. What is the difference between the Number of enrolments of both sexes in Macao in 1979 and the Number of enrolments of both sexes in Uruguay in 1999?
Give a very brief answer. -2.69e+05. What is the difference between the Number of enrolments of both sexes in Iceland in 1979 and the Number of enrolments of both sexes in Kiribati in 2000?
Provide a succinct answer. 1.92e+04. What is the difference between the Number of enrolments of both sexes in Iceland in 1979 and the Number of enrolments of both sexes in Macao in 2000?
Provide a succinct answer. -8668. What is the difference between the Number of enrolments of both sexes in Iceland in 1979 and the Number of enrolments of both sexes in Uruguay in 2000?
Offer a very short reply. -2.77e+05. What is the difference between the Number of enrolments of both sexes in Kiribati in 1979 and the Number of enrolments of both sexes in Macao in 2000?
Provide a succinct answer. -3.33e+04. What is the difference between the Number of enrolments of both sexes of Kiribati in 1979 and the Number of enrolments of both sexes of Uruguay in 2000?
Your response must be concise. -3.02e+05. What is the difference between the Number of enrolments of both sexes in Macao in 1979 and the Number of enrolments of both sexes in Uruguay in 2000?
Provide a short and direct response. -2.89e+05. What is the difference between the Number of enrolments of both sexes in Iceland in 1990 and the Number of enrolments of both sexes in Kiribati in 1992?
Your answer should be very brief. 2.57e+04. What is the difference between the Number of enrolments of both sexes of Iceland in 1990 and the Number of enrolments of both sexes of Macao in 1992?
Your response must be concise. 1.01e+04. What is the difference between the Number of enrolments of both sexes of Iceland in 1990 and the Number of enrolments of both sexes of Uruguay in 1992?
Your answer should be compact. -2.44e+05. What is the difference between the Number of enrolments of both sexes in Kiribati in 1990 and the Number of enrolments of both sexes in Macao in 1992?
Make the answer very short. -1.60e+04. What is the difference between the Number of enrolments of both sexes of Kiribati in 1990 and the Number of enrolments of both sexes of Uruguay in 1992?
Offer a very short reply. -2.70e+05. What is the difference between the Number of enrolments of both sexes of Macao in 1990 and the Number of enrolments of both sexes of Uruguay in 1992?
Your answer should be compact. -2.56e+05. What is the difference between the Number of enrolments of both sexes of Iceland in 1990 and the Number of enrolments of both sexes of Kiribati in 1999?
Your response must be concise. 2.24e+04. What is the difference between the Number of enrolments of both sexes in Iceland in 1990 and the Number of enrolments of both sexes in Macao in 1999?
Your answer should be compact. -2800. What is the difference between the Number of enrolments of both sexes in Iceland in 1990 and the Number of enrolments of both sexes in Uruguay in 1999?
Give a very brief answer. -2.55e+05. What is the difference between the Number of enrolments of both sexes of Kiribati in 1990 and the Number of enrolments of both sexes of Macao in 1999?
Provide a short and direct response. -2.89e+04. What is the difference between the Number of enrolments of both sexes of Kiribati in 1990 and the Number of enrolments of both sexes of Uruguay in 1999?
Offer a terse response. -2.81e+05. What is the difference between the Number of enrolments of both sexes in Macao in 1990 and the Number of enrolments of both sexes in Uruguay in 1999?
Your answer should be compact. -2.67e+05. What is the difference between the Number of enrolments of both sexes in Iceland in 1990 and the Number of enrolments of both sexes in Kiribati in 2000?
Your answer should be very brief. 2.16e+04. What is the difference between the Number of enrolments of both sexes in Iceland in 1990 and the Number of enrolments of both sexes in Macao in 2000?
Provide a succinct answer. -6308. What is the difference between the Number of enrolments of both sexes of Iceland in 1990 and the Number of enrolments of both sexes of Uruguay in 2000?
Your answer should be very brief. -2.75e+05. What is the difference between the Number of enrolments of both sexes of Kiribati in 1990 and the Number of enrolments of both sexes of Macao in 2000?
Offer a terse response. -3.24e+04. What is the difference between the Number of enrolments of both sexes in Kiribati in 1990 and the Number of enrolments of both sexes in Uruguay in 2000?
Your answer should be compact. -3.01e+05. What is the difference between the Number of enrolments of both sexes in Macao in 1990 and the Number of enrolments of both sexes in Uruguay in 2000?
Keep it short and to the point. -2.87e+05. What is the difference between the Number of enrolments of both sexes in Iceland in 1992 and the Number of enrolments of both sexes in Kiribati in 1999?
Ensure brevity in your answer.  2.33e+04. What is the difference between the Number of enrolments of both sexes in Iceland in 1992 and the Number of enrolments of both sexes in Macao in 1999?
Your response must be concise. -1874. What is the difference between the Number of enrolments of both sexes in Iceland in 1992 and the Number of enrolments of both sexes in Uruguay in 1999?
Provide a short and direct response. -2.54e+05. What is the difference between the Number of enrolments of both sexes of Kiribati in 1992 and the Number of enrolments of both sexes of Macao in 1999?
Offer a very short reply. -2.85e+04. What is the difference between the Number of enrolments of both sexes of Kiribati in 1992 and the Number of enrolments of both sexes of Uruguay in 1999?
Keep it short and to the point. -2.80e+05. What is the difference between the Number of enrolments of both sexes in Macao in 1992 and the Number of enrolments of both sexes in Uruguay in 1999?
Provide a succinct answer. -2.65e+05. What is the difference between the Number of enrolments of both sexes of Iceland in 1992 and the Number of enrolments of both sexes of Kiribati in 2000?
Offer a very short reply. 2.25e+04. What is the difference between the Number of enrolments of both sexes of Iceland in 1992 and the Number of enrolments of both sexes of Macao in 2000?
Your answer should be compact. -5382. What is the difference between the Number of enrolments of both sexes in Iceland in 1992 and the Number of enrolments of both sexes in Uruguay in 2000?
Your response must be concise. -2.74e+05. What is the difference between the Number of enrolments of both sexes of Kiribati in 1992 and the Number of enrolments of both sexes of Macao in 2000?
Ensure brevity in your answer.  -3.20e+04. What is the difference between the Number of enrolments of both sexes in Kiribati in 1992 and the Number of enrolments of both sexes in Uruguay in 2000?
Ensure brevity in your answer.  -3.01e+05. What is the difference between the Number of enrolments of both sexes in Macao in 1992 and the Number of enrolments of both sexes in Uruguay in 2000?
Provide a short and direct response. -2.85e+05. What is the difference between the Number of enrolments of both sexes in Iceland in 1999 and the Number of enrolments of both sexes in Kiribati in 2000?
Provide a succinct answer. 2.50e+04. What is the difference between the Number of enrolments of both sexes of Iceland in 1999 and the Number of enrolments of both sexes of Macao in 2000?
Make the answer very short. -2887. What is the difference between the Number of enrolments of both sexes in Iceland in 1999 and the Number of enrolments of both sexes in Uruguay in 2000?
Offer a very short reply. -2.71e+05. What is the difference between the Number of enrolments of both sexes in Kiribati in 1999 and the Number of enrolments of both sexes in Macao in 2000?
Give a very brief answer. -2.87e+04. What is the difference between the Number of enrolments of both sexes in Kiribati in 1999 and the Number of enrolments of both sexes in Uruguay in 2000?
Give a very brief answer. -2.97e+05. What is the difference between the Number of enrolments of both sexes of Macao in 1999 and the Number of enrolments of both sexes of Uruguay in 2000?
Provide a succinct answer. -2.72e+05. What is the average Number of enrolments of both sexes in Iceland per year?
Offer a terse response. 2.85e+04. What is the average Number of enrolments of both sexes in Kiribati per year?
Provide a succinct answer. 3325.12. What is the average Number of enrolments of both sexes in Macao per year?
Provide a short and direct response. 1.94e+04. What is the average Number of enrolments of both sexes in Uruguay per year?
Your response must be concise. 2.30e+05. In the year 1975, what is the difference between the Number of enrolments of both sexes in Iceland and Number of enrolments of both sexes in Kiribati?
Keep it short and to the point. 2.39e+04. In the year 1975, what is the difference between the Number of enrolments of both sexes of Iceland and Number of enrolments of both sexes of Macao?
Offer a terse response. 1.55e+04. In the year 1975, what is the difference between the Number of enrolments of both sexes of Iceland and Number of enrolments of both sexes of Uruguay?
Your response must be concise. -1.57e+05. In the year 1975, what is the difference between the Number of enrolments of both sexes of Kiribati and Number of enrolments of both sexes of Macao?
Ensure brevity in your answer.  -8398. In the year 1975, what is the difference between the Number of enrolments of both sexes of Kiribati and Number of enrolments of both sexes of Uruguay?
Your answer should be very brief. -1.81e+05. In the year 1975, what is the difference between the Number of enrolments of both sexes in Macao and Number of enrolments of both sexes in Uruguay?
Ensure brevity in your answer.  -1.73e+05. In the year 1977, what is the difference between the Number of enrolments of both sexes of Iceland and Number of enrolments of both sexes of Kiribati?
Offer a very short reply. 2.52e+04. In the year 1977, what is the difference between the Number of enrolments of both sexes in Iceland and Number of enrolments of both sexes in Macao?
Your answer should be compact. 1.22e+04. In the year 1977, what is the difference between the Number of enrolments of both sexes of Iceland and Number of enrolments of both sexes of Uruguay?
Ensure brevity in your answer.  -1.54e+05. In the year 1977, what is the difference between the Number of enrolments of both sexes of Kiribati and Number of enrolments of both sexes of Macao?
Your answer should be compact. -1.30e+04. In the year 1977, what is the difference between the Number of enrolments of both sexes in Kiribati and Number of enrolments of both sexes in Uruguay?
Your answer should be compact. -1.79e+05. In the year 1977, what is the difference between the Number of enrolments of both sexes in Macao and Number of enrolments of both sexes in Uruguay?
Provide a short and direct response. -1.66e+05. In the year 1978, what is the difference between the Number of enrolments of both sexes in Iceland and Number of enrolments of both sexes in Kiribati?
Offer a terse response. 2.46e+04. In the year 1978, what is the difference between the Number of enrolments of both sexes in Iceland and Number of enrolments of both sexes in Macao?
Your response must be concise. 1.31e+04. In the year 1978, what is the difference between the Number of enrolments of both sexes of Iceland and Number of enrolments of both sexes of Uruguay?
Your response must be concise. -1.50e+05. In the year 1978, what is the difference between the Number of enrolments of both sexes of Kiribati and Number of enrolments of both sexes of Macao?
Give a very brief answer. -1.15e+04. In the year 1978, what is the difference between the Number of enrolments of both sexes in Kiribati and Number of enrolments of both sexes in Uruguay?
Your answer should be very brief. -1.75e+05. In the year 1978, what is the difference between the Number of enrolments of both sexes in Macao and Number of enrolments of both sexes in Uruguay?
Your answer should be very brief. -1.63e+05. In the year 1979, what is the difference between the Number of enrolments of both sexes in Iceland and Number of enrolments of both sexes in Kiribati?
Offer a terse response. 2.46e+04. In the year 1979, what is the difference between the Number of enrolments of both sexes of Iceland and Number of enrolments of both sexes of Macao?
Offer a very short reply. 1.14e+04. In the year 1979, what is the difference between the Number of enrolments of both sexes in Iceland and Number of enrolments of both sexes in Uruguay?
Offer a terse response. -1.46e+05. In the year 1979, what is the difference between the Number of enrolments of both sexes in Kiribati and Number of enrolments of both sexes in Macao?
Your answer should be compact. -1.32e+04. In the year 1979, what is the difference between the Number of enrolments of both sexes of Kiribati and Number of enrolments of both sexes of Uruguay?
Provide a succinct answer. -1.71e+05. In the year 1979, what is the difference between the Number of enrolments of both sexes of Macao and Number of enrolments of both sexes of Uruguay?
Provide a succinct answer. -1.58e+05. In the year 1990, what is the difference between the Number of enrolments of both sexes of Iceland and Number of enrolments of both sexes of Kiribati?
Your answer should be very brief. 2.61e+04. In the year 1990, what is the difference between the Number of enrolments of both sexes in Iceland and Number of enrolments of both sexes in Macao?
Provide a succinct answer. 1.24e+04. In the year 1990, what is the difference between the Number of enrolments of both sexes in Iceland and Number of enrolments of both sexes in Uruguay?
Your answer should be very brief. -2.37e+05. In the year 1990, what is the difference between the Number of enrolments of both sexes of Kiribati and Number of enrolments of both sexes of Macao?
Keep it short and to the point. -1.37e+04. In the year 1990, what is the difference between the Number of enrolments of both sexes of Kiribati and Number of enrolments of both sexes of Uruguay?
Your response must be concise. -2.63e+05. In the year 1990, what is the difference between the Number of enrolments of both sexes in Macao and Number of enrolments of both sexes in Uruguay?
Make the answer very short. -2.49e+05. In the year 1992, what is the difference between the Number of enrolments of both sexes of Iceland and Number of enrolments of both sexes of Kiribati?
Offer a very short reply. 2.66e+04. In the year 1992, what is the difference between the Number of enrolments of both sexes in Iceland and Number of enrolments of both sexes in Macao?
Your answer should be very brief. 1.10e+04. In the year 1992, what is the difference between the Number of enrolments of both sexes in Iceland and Number of enrolments of both sexes in Uruguay?
Provide a succinct answer. -2.43e+05. In the year 1992, what is the difference between the Number of enrolments of both sexes in Kiribati and Number of enrolments of both sexes in Macao?
Your response must be concise. -1.56e+04. In the year 1992, what is the difference between the Number of enrolments of both sexes in Kiribati and Number of enrolments of both sexes in Uruguay?
Keep it short and to the point. -2.69e+05. In the year 1992, what is the difference between the Number of enrolments of both sexes of Macao and Number of enrolments of both sexes of Uruguay?
Give a very brief answer. -2.54e+05. In the year 1999, what is the difference between the Number of enrolments of both sexes in Iceland and Number of enrolments of both sexes in Kiribati?
Keep it short and to the point. 2.58e+04. In the year 1999, what is the difference between the Number of enrolments of both sexes in Iceland and Number of enrolments of both sexes in Macao?
Ensure brevity in your answer.  621. In the year 1999, what is the difference between the Number of enrolments of both sexes of Iceland and Number of enrolments of both sexes of Uruguay?
Ensure brevity in your answer.  -2.51e+05. In the year 1999, what is the difference between the Number of enrolments of both sexes in Kiribati and Number of enrolments of both sexes in Macao?
Offer a terse response. -2.52e+04. In the year 1999, what is the difference between the Number of enrolments of both sexes in Kiribati and Number of enrolments of both sexes in Uruguay?
Ensure brevity in your answer.  -2.77e+05. In the year 1999, what is the difference between the Number of enrolments of both sexes in Macao and Number of enrolments of both sexes in Uruguay?
Make the answer very short. -2.52e+05. In the year 2000, what is the difference between the Number of enrolments of both sexes of Iceland and Number of enrolments of both sexes of Kiribati?
Provide a short and direct response. 2.46e+04. In the year 2000, what is the difference between the Number of enrolments of both sexes of Iceland and Number of enrolments of both sexes of Macao?
Provide a succinct answer. -3234. In the year 2000, what is the difference between the Number of enrolments of both sexes of Iceland and Number of enrolments of both sexes of Uruguay?
Give a very brief answer. -2.72e+05. In the year 2000, what is the difference between the Number of enrolments of both sexes of Kiribati and Number of enrolments of both sexes of Macao?
Ensure brevity in your answer.  -2.79e+04. In the year 2000, what is the difference between the Number of enrolments of both sexes in Kiribati and Number of enrolments of both sexes in Uruguay?
Offer a very short reply. -2.96e+05. In the year 2000, what is the difference between the Number of enrolments of both sexes in Macao and Number of enrolments of both sexes in Uruguay?
Give a very brief answer. -2.69e+05. What is the ratio of the Number of enrolments of both sexes of Iceland in 1975 to that in 1977?
Give a very brief answer. 0.94. What is the ratio of the Number of enrolments of both sexes in Kiribati in 1975 to that in 1977?
Keep it short and to the point. 0.85. What is the ratio of the Number of enrolments of both sexes in Macao in 1975 to that in 1977?
Provide a succinct answer. 0.66. What is the ratio of the Number of enrolments of both sexes in Uruguay in 1975 to that in 1977?
Your answer should be very brief. 1.01. What is the ratio of the Number of enrolments of both sexes in Iceland in 1975 to that in 1978?
Ensure brevity in your answer.  0.95. What is the ratio of the Number of enrolments of both sexes in Kiribati in 1975 to that in 1978?
Your answer should be compact. 0.67. What is the ratio of the Number of enrolments of both sexes in Macao in 1975 to that in 1978?
Offer a very short reply. 0.72. What is the ratio of the Number of enrolments of both sexes of Uruguay in 1975 to that in 1978?
Keep it short and to the point. 1.03. What is the ratio of the Number of enrolments of both sexes in Iceland in 1975 to that in 1979?
Make the answer very short. 0.94. What is the ratio of the Number of enrolments of both sexes of Kiribati in 1975 to that in 1979?
Ensure brevity in your answer.  0.53. What is the ratio of the Number of enrolments of both sexes in Macao in 1975 to that in 1979?
Your answer should be compact. 0.62. What is the ratio of the Number of enrolments of both sexes of Uruguay in 1975 to that in 1979?
Your response must be concise. 1.05. What is the ratio of the Number of enrolments of both sexes in Iceland in 1975 to that in 1990?
Ensure brevity in your answer.  0.86. What is the ratio of the Number of enrolments of both sexes of Kiribati in 1975 to that in 1990?
Your answer should be compact. 0.37. What is the ratio of the Number of enrolments of both sexes of Macao in 1975 to that in 1990?
Ensure brevity in your answer.  0.57. What is the ratio of the Number of enrolments of both sexes in Uruguay in 1975 to that in 1990?
Offer a terse response. 0.69. What is the ratio of the Number of enrolments of both sexes of Iceland in 1975 to that in 1992?
Provide a succinct answer. 0.83. What is the ratio of the Number of enrolments of both sexes in Kiribati in 1975 to that in 1992?
Offer a very short reply. 0.33. What is the ratio of the Number of enrolments of both sexes of Macao in 1975 to that in 1992?
Give a very brief answer. 0.5. What is the ratio of the Number of enrolments of both sexes in Uruguay in 1975 to that in 1992?
Provide a succinct answer. 0.67. What is the ratio of the Number of enrolments of both sexes of Iceland in 1975 to that in 1999?
Ensure brevity in your answer.  0.77. What is the ratio of the Number of enrolments of both sexes in Kiribati in 1975 to that in 1999?
Make the answer very short. 0.17. What is the ratio of the Number of enrolments of both sexes in Macao in 1975 to that in 1999?
Offer a terse response. 0.3. What is the ratio of the Number of enrolments of both sexes of Uruguay in 1975 to that in 1999?
Ensure brevity in your answer.  0.64. What is the ratio of the Number of enrolments of both sexes in Iceland in 1975 to that in 2000?
Your response must be concise. 0.78. What is the ratio of the Number of enrolments of both sexes of Kiribati in 1975 to that in 2000?
Provide a succinct answer. 0.15. What is the ratio of the Number of enrolments of both sexes in Macao in 1975 to that in 2000?
Offer a very short reply. 0.27. What is the ratio of the Number of enrolments of both sexes in Uruguay in 1975 to that in 2000?
Give a very brief answer. 0.6. What is the ratio of the Number of enrolments of both sexes of Iceland in 1977 to that in 1978?
Provide a short and direct response. 1.01. What is the ratio of the Number of enrolments of both sexes of Kiribati in 1977 to that in 1978?
Give a very brief answer. 0.79. What is the ratio of the Number of enrolments of both sexes in Macao in 1977 to that in 1978?
Offer a very short reply. 1.09. What is the ratio of the Number of enrolments of both sexes of Uruguay in 1977 to that in 1978?
Offer a very short reply. 1.02. What is the ratio of the Number of enrolments of both sexes of Iceland in 1977 to that in 1979?
Make the answer very short. 0.99. What is the ratio of the Number of enrolments of both sexes of Kiribati in 1977 to that in 1979?
Provide a succinct answer. 0.63. What is the ratio of the Number of enrolments of both sexes of Macao in 1977 to that in 1979?
Provide a short and direct response. 0.94. What is the ratio of the Number of enrolments of both sexes of Uruguay in 1977 to that in 1979?
Your answer should be compact. 1.04. What is the ratio of the Number of enrolments of both sexes in Iceland in 1977 to that in 1990?
Provide a short and direct response. 0.91. What is the ratio of the Number of enrolments of both sexes in Kiribati in 1977 to that in 1990?
Keep it short and to the point. 0.43. What is the ratio of the Number of enrolments of both sexes of Macao in 1977 to that in 1990?
Provide a succinct answer. 0.86. What is the ratio of the Number of enrolments of both sexes of Uruguay in 1977 to that in 1990?
Ensure brevity in your answer.  0.68. What is the ratio of the Number of enrolments of both sexes of Iceland in 1977 to that in 1992?
Your answer should be very brief. 0.88. What is the ratio of the Number of enrolments of both sexes of Kiribati in 1977 to that in 1992?
Make the answer very short. 0.39. What is the ratio of the Number of enrolments of both sexes of Macao in 1977 to that in 1992?
Provide a short and direct response. 0.75. What is the ratio of the Number of enrolments of both sexes of Uruguay in 1977 to that in 1992?
Your answer should be compact. 0.66. What is the ratio of the Number of enrolments of both sexes of Iceland in 1977 to that in 1999?
Provide a succinct answer. 0.82. What is the ratio of the Number of enrolments of both sexes in Kiribati in 1977 to that in 1999?
Your answer should be very brief. 0.2. What is the ratio of the Number of enrolments of both sexes in Macao in 1977 to that in 1999?
Give a very brief answer. 0.45. What is the ratio of the Number of enrolments of both sexes of Uruguay in 1977 to that in 1999?
Your answer should be very brief. 0.64. What is the ratio of the Number of enrolments of both sexes of Iceland in 1977 to that in 2000?
Offer a terse response. 0.82. What is the ratio of the Number of enrolments of both sexes of Kiribati in 1977 to that in 2000?
Offer a terse response. 0.17. What is the ratio of the Number of enrolments of both sexes in Macao in 1977 to that in 2000?
Offer a very short reply. 0.4. What is the ratio of the Number of enrolments of both sexes of Uruguay in 1977 to that in 2000?
Provide a short and direct response. 0.59. What is the ratio of the Number of enrolments of both sexes of Iceland in 1978 to that in 1979?
Your response must be concise. 0.98. What is the ratio of the Number of enrolments of both sexes of Kiribati in 1978 to that in 1979?
Your answer should be compact. 0.8. What is the ratio of the Number of enrolments of both sexes in Macao in 1978 to that in 1979?
Offer a very short reply. 0.86. What is the ratio of the Number of enrolments of both sexes of Uruguay in 1978 to that in 1979?
Ensure brevity in your answer.  1.02. What is the ratio of the Number of enrolments of both sexes of Iceland in 1978 to that in 1990?
Your answer should be very brief. 0.9. What is the ratio of the Number of enrolments of both sexes of Kiribati in 1978 to that in 1990?
Ensure brevity in your answer.  0.55. What is the ratio of the Number of enrolments of both sexes in Macao in 1978 to that in 1990?
Make the answer very short. 0.79. What is the ratio of the Number of enrolments of both sexes of Uruguay in 1978 to that in 1990?
Your answer should be compact. 0.66. What is the ratio of the Number of enrolments of both sexes of Iceland in 1978 to that in 1992?
Give a very brief answer. 0.88. What is the ratio of the Number of enrolments of both sexes of Kiribati in 1978 to that in 1992?
Offer a very short reply. 0.49. What is the ratio of the Number of enrolments of both sexes in Macao in 1978 to that in 1992?
Your response must be concise. 0.69. What is the ratio of the Number of enrolments of both sexes of Uruguay in 1978 to that in 1992?
Keep it short and to the point. 0.65. What is the ratio of the Number of enrolments of both sexes in Iceland in 1978 to that in 1999?
Your answer should be compact. 0.81. What is the ratio of the Number of enrolments of both sexes in Kiribati in 1978 to that in 1999?
Keep it short and to the point. 0.25. What is the ratio of the Number of enrolments of both sexes of Macao in 1978 to that in 1999?
Offer a terse response. 0.41. What is the ratio of the Number of enrolments of both sexes in Uruguay in 1978 to that in 1999?
Offer a very short reply. 0.62. What is the ratio of the Number of enrolments of both sexes in Iceland in 1978 to that in 2000?
Offer a very short reply. 0.82. What is the ratio of the Number of enrolments of both sexes in Kiribati in 1978 to that in 2000?
Your answer should be compact. 0.22. What is the ratio of the Number of enrolments of both sexes of Macao in 1978 to that in 2000?
Give a very brief answer. 0.37. What is the ratio of the Number of enrolments of both sexes in Uruguay in 1978 to that in 2000?
Ensure brevity in your answer.  0.58. What is the ratio of the Number of enrolments of both sexes in Iceland in 1979 to that in 1990?
Ensure brevity in your answer.  0.92. What is the ratio of the Number of enrolments of both sexes of Kiribati in 1979 to that in 1990?
Offer a terse response. 0.69. What is the ratio of the Number of enrolments of both sexes in Macao in 1979 to that in 1990?
Make the answer very short. 0.92. What is the ratio of the Number of enrolments of both sexes of Uruguay in 1979 to that in 1990?
Ensure brevity in your answer.  0.65. What is the ratio of the Number of enrolments of both sexes of Iceland in 1979 to that in 1992?
Ensure brevity in your answer.  0.89. What is the ratio of the Number of enrolments of both sexes in Kiribati in 1979 to that in 1992?
Your response must be concise. 0.61. What is the ratio of the Number of enrolments of both sexes in Macao in 1979 to that in 1992?
Keep it short and to the point. 0.8. What is the ratio of the Number of enrolments of both sexes of Uruguay in 1979 to that in 1992?
Make the answer very short. 0.63. What is the ratio of the Number of enrolments of both sexes of Iceland in 1979 to that in 1999?
Ensure brevity in your answer.  0.82. What is the ratio of the Number of enrolments of both sexes of Kiribati in 1979 to that in 1999?
Provide a short and direct response. 0.31. What is the ratio of the Number of enrolments of both sexes of Macao in 1979 to that in 1999?
Your answer should be compact. 0.48. What is the ratio of the Number of enrolments of both sexes in Uruguay in 1979 to that in 1999?
Your answer should be compact. 0.61. What is the ratio of the Number of enrolments of both sexes of Iceland in 1979 to that in 2000?
Your answer should be compact. 0.83. What is the ratio of the Number of enrolments of both sexes in Kiribati in 1979 to that in 2000?
Your response must be concise. 0.28. What is the ratio of the Number of enrolments of both sexes of Macao in 1979 to that in 2000?
Your answer should be very brief. 0.43. What is the ratio of the Number of enrolments of both sexes in Uruguay in 1979 to that in 2000?
Offer a terse response. 0.57. What is the ratio of the Number of enrolments of both sexes in Iceland in 1990 to that in 1992?
Your answer should be compact. 0.97. What is the ratio of the Number of enrolments of both sexes of Kiribati in 1990 to that in 1992?
Provide a succinct answer. 0.89. What is the ratio of the Number of enrolments of both sexes in Macao in 1990 to that in 1992?
Offer a very short reply. 0.88. What is the ratio of the Number of enrolments of both sexes of Uruguay in 1990 to that in 1992?
Make the answer very short. 0.98. What is the ratio of the Number of enrolments of both sexes in Iceland in 1990 to that in 1999?
Give a very brief answer. 0.89. What is the ratio of the Number of enrolments of both sexes in Kiribati in 1990 to that in 1999?
Make the answer very short. 0.45. What is the ratio of the Number of enrolments of both sexes of Macao in 1990 to that in 1999?
Ensure brevity in your answer.  0.52. What is the ratio of the Number of enrolments of both sexes in Uruguay in 1990 to that in 1999?
Offer a terse response. 0.94. What is the ratio of the Number of enrolments of both sexes in Iceland in 1990 to that in 2000?
Your response must be concise. 0.9. What is the ratio of the Number of enrolments of both sexes in Kiribati in 1990 to that in 2000?
Give a very brief answer. 0.4. What is the ratio of the Number of enrolments of both sexes of Macao in 1990 to that in 2000?
Your answer should be very brief. 0.47. What is the ratio of the Number of enrolments of both sexes of Uruguay in 1990 to that in 2000?
Your answer should be very brief. 0.88. What is the ratio of the Number of enrolments of both sexes of Iceland in 1992 to that in 1999?
Keep it short and to the point. 0.92. What is the ratio of the Number of enrolments of both sexes in Kiribati in 1992 to that in 1999?
Your response must be concise. 0.51. What is the ratio of the Number of enrolments of both sexes of Macao in 1992 to that in 1999?
Give a very brief answer. 0.6. What is the ratio of the Number of enrolments of both sexes of Uruguay in 1992 to that in 1999?
Your response must be concise. 0.96. What is the ratio of the Number of enrolments of both sexes in Iceland in 1992 to that in 2000?
Ensure brevity in your answer.  0.93. What is the ratio of the Number of enrolments of both sexes in Kiribati in 1992 to that in 2000?
Provide a succinct answer. 0.45. What is the ratio of the Number of enrolments of both sexes in Macao in 1992 to that in 2000?
Your answer should be very brief. 0.54. What is the ratio of the Number of enrolments of both sexes of Uruguay in 1992 to that in 2000?
Provide a succinct answer. 0.9. What is the ratio of the Number of enrolments of both sexes in Iceland in 1999 to that in 2000?
Keep it short and to the point. 1.01. What is the ratio of the Number of enrolments of both sexes in Kiribati in 1999 to that in 2000?
Your answer should be very brief. 0.89. What is the ratio of the Number of enrolments of both sexes of Macao in 1999 to that in 2000?
Provide a succinct answer. 0.9. What is the ratio of the Number of enrolments of both sexes in Uruguay in 1999 to that in 2000?
Offer a terse response. 0.93. What is the difference between the highest and the second highest Number of enrolments of both sexes of Iceland?
Make the answer very short. 347. What is the difference between the highest and the second highest Number of enrolments of both sexes in Kiribati?
Offer a very short reply. 839. What is the difference between the highest and the second highest Number of enrolments of both sexes of Macao?
Make the answer very short. 3508. What is the difference between the highest and the second highest Number of enrolments of both sexes in Uruguay?
Offer a very short reply. 2.00e+04. What is the difference between the highest and the lowest Number of enrolments of both sexes in Iceland?
Your response must be concise. 7452. What is the difference between the highest and the lowest Number of enrolments of both sexes of Kiribati?
Keep it short and to the point. 6386. What is the difference between the highest and the lowest Number of enrolments of both sexes of Macao?
Keep it short and to the point. 2.59e+04. What is the difference between the highest and the lowest Number of enrolments of both sexes of Uruguay?
Keep it short and to the point. 1.31e+05. 